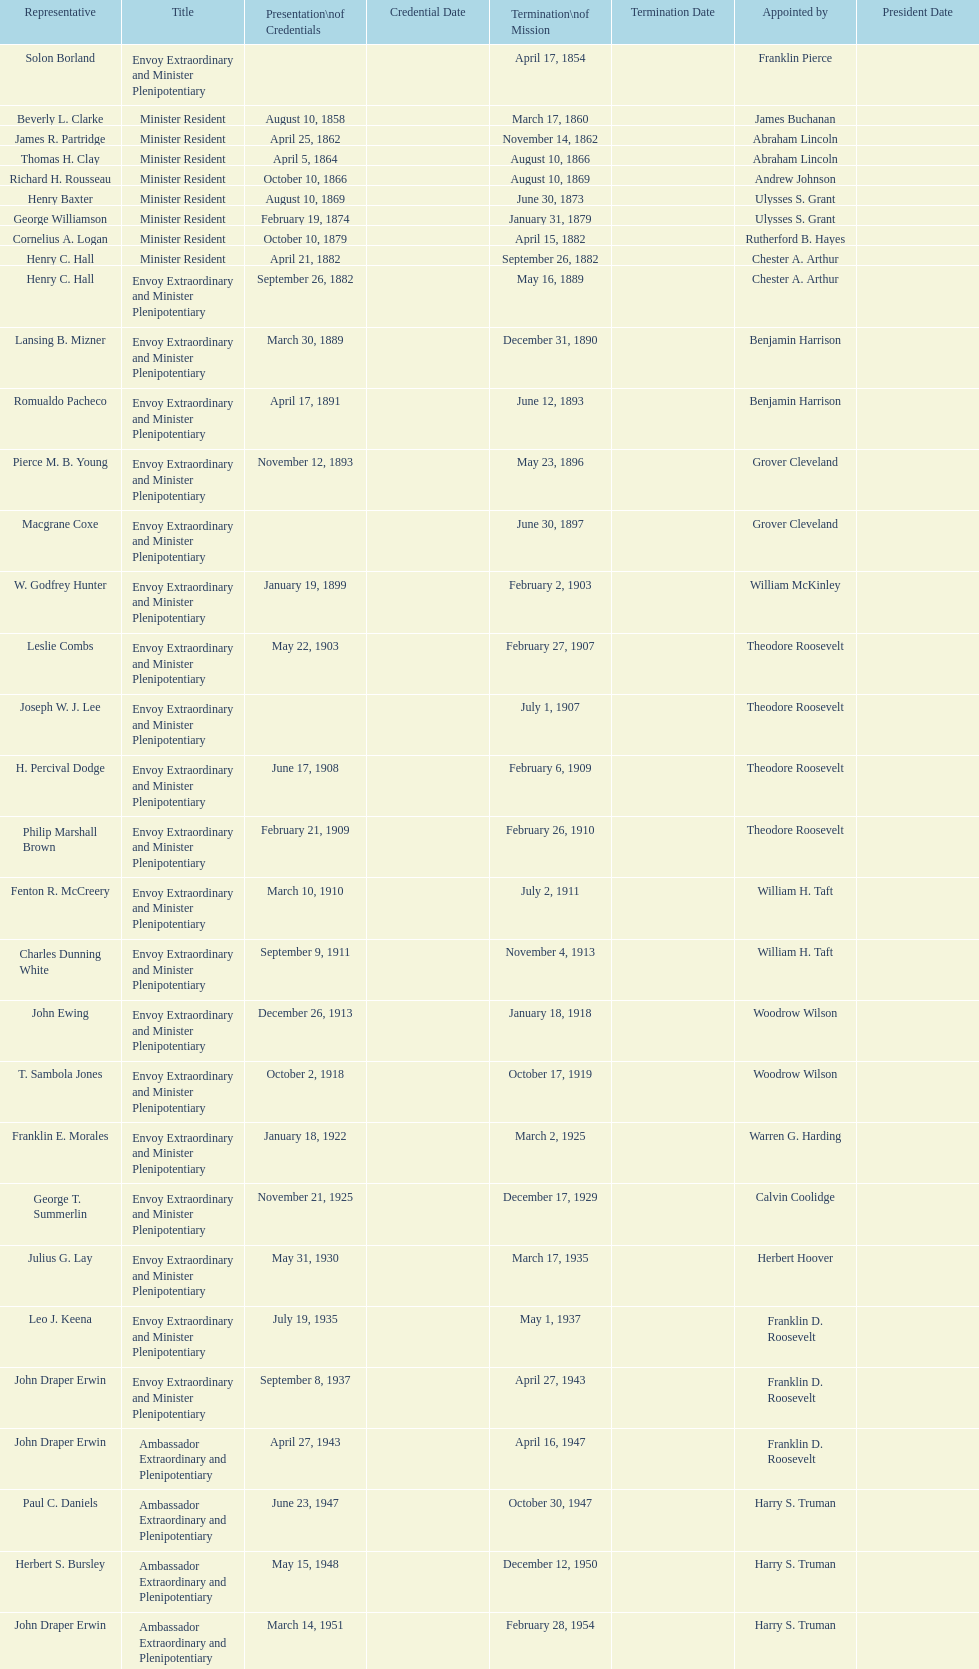Is solon borland a representative? Yes. 